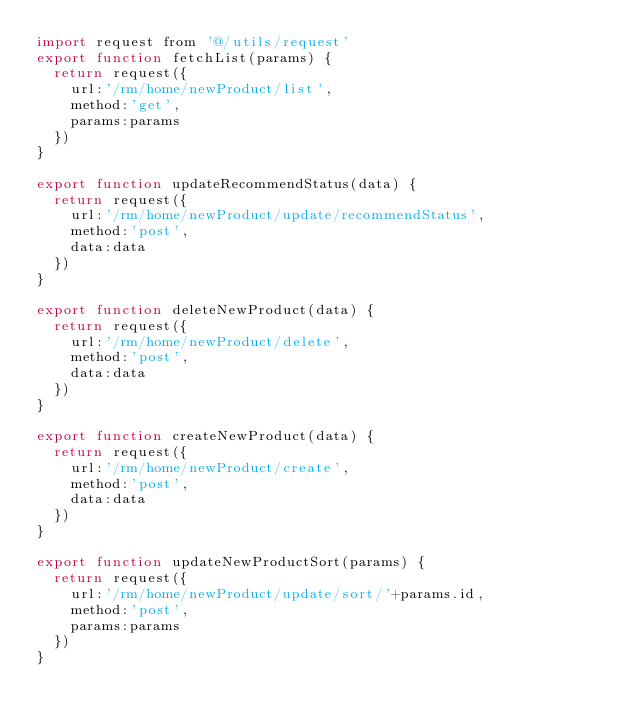<code> <loc_0><loc_0><loc_500><loc_500><_JavaScript_>import request from '@/utils/request'
export function fetchList(params) {
  return request({
    url:'/rm/home/newProduct/list',
    method:'get',
    params:params
  })
}

export function updateRecommendStatus(data) {
  return request({
    url:'/rm/home/newProduct/update/recommendStatus',
    method:'post',
    data:data
  })
}

export function deleteNewProduct(data) {
  return request({
    url:'/rm/home/newProduct/delete',
    method:'post',
    data:data
  })
}

export function createNewProduct(data) {
  return request({
    url:'/rm/home/newProduct/create',
    method:'post',
    data:data
  })
}

export function updateNewProductSort(params) {
  return request({
    url:'/rm/home/newProduct/update/sort/'+params.id,
    method:'post',
    params:params
  })
}
</code> 